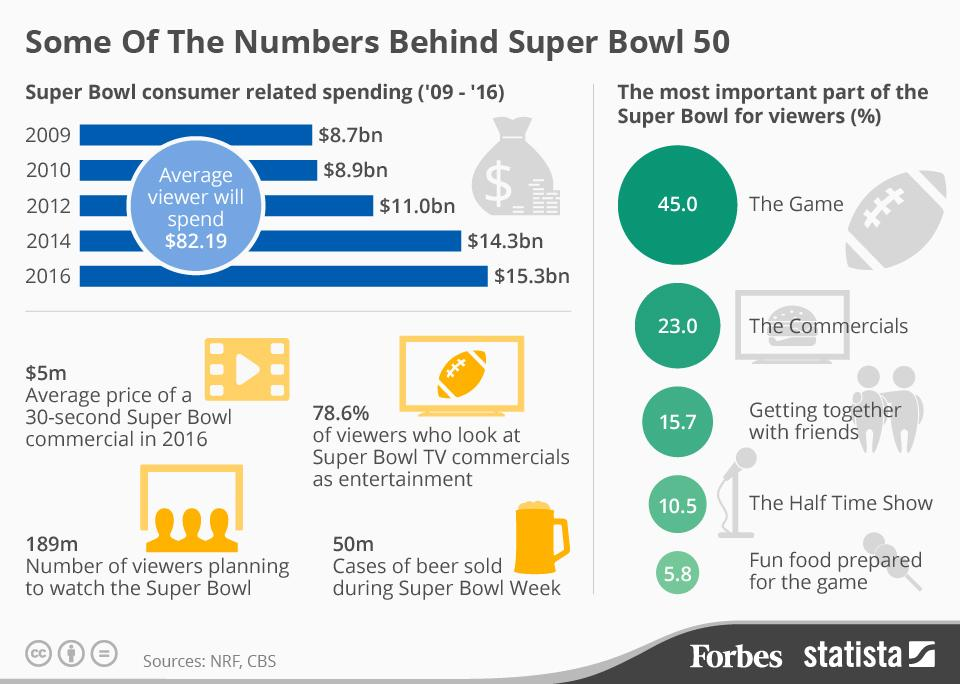Draw attention to some important aspects in this diagram. In 2014, the amount that consumers spent on the Super Bowl was $14.3 billion. In 2016, the average price of a 30-second Super Bowl commercial was $5 million. According to estimates, 189 million people are expected to tune in and watch the Super Bowl 50. According to a survey of Super Bowl viewers, 23.0% believe that the commercials are the most important aspect of the game. According to data, during the week of the Super Bowl, an estimated 50 million cases of beer were sold in the United States. 